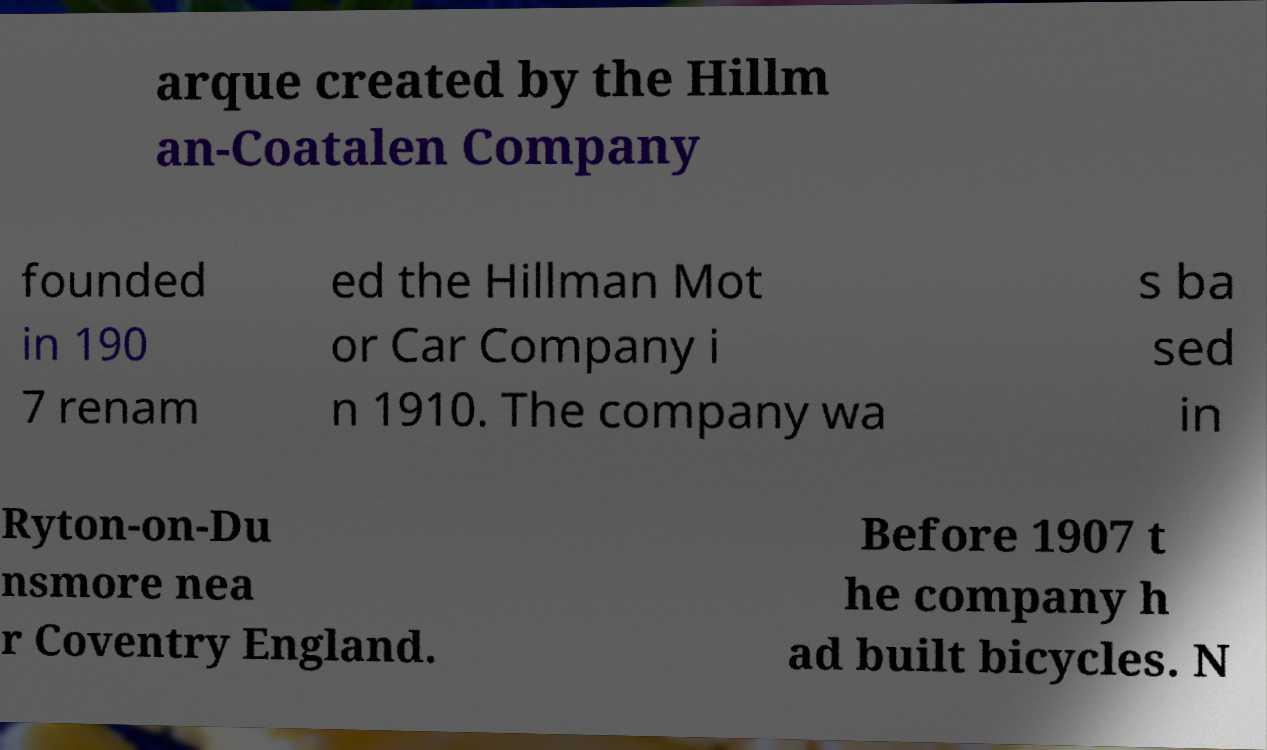Please identify and transcribe the text found in this image. arque created by the Hillm an-Coatalen Company founded in 190 7 renam ed the Hillman Mot or Car Company i n 1910. The company wa s ba sed in Ryton-on-Du nsmore nea r Coventry England. Before 1907 t he company h ad built bicycles. N 